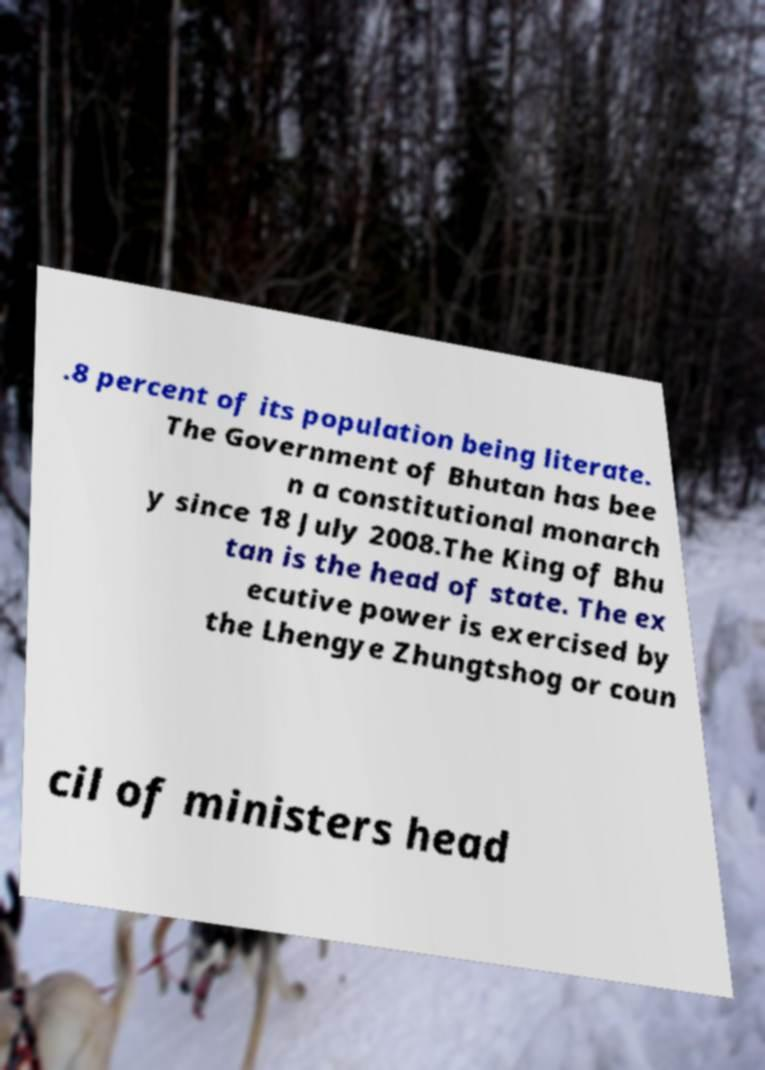Could you extract and type out the text from this image? .8 percent of its population being literate. The Government of Bhutan has bee n a constitutional monarch y since 18 July 2008.The King of Bhu tan is the head of state. The ex ecutive power is exercised by the Lhengye Zhungtshog or coun cil of ministers head 